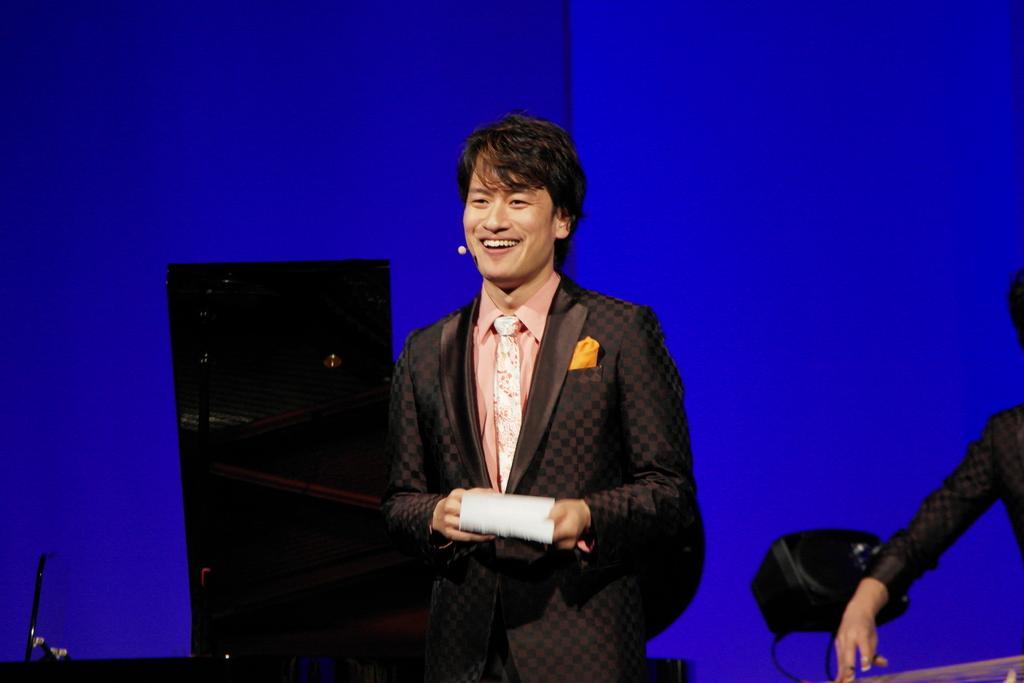How would you summarize this image in a sentence or two? A person is standing wearing a suit and holding some object in his hand. There is a hand of a person on the right. There is a blue background. 